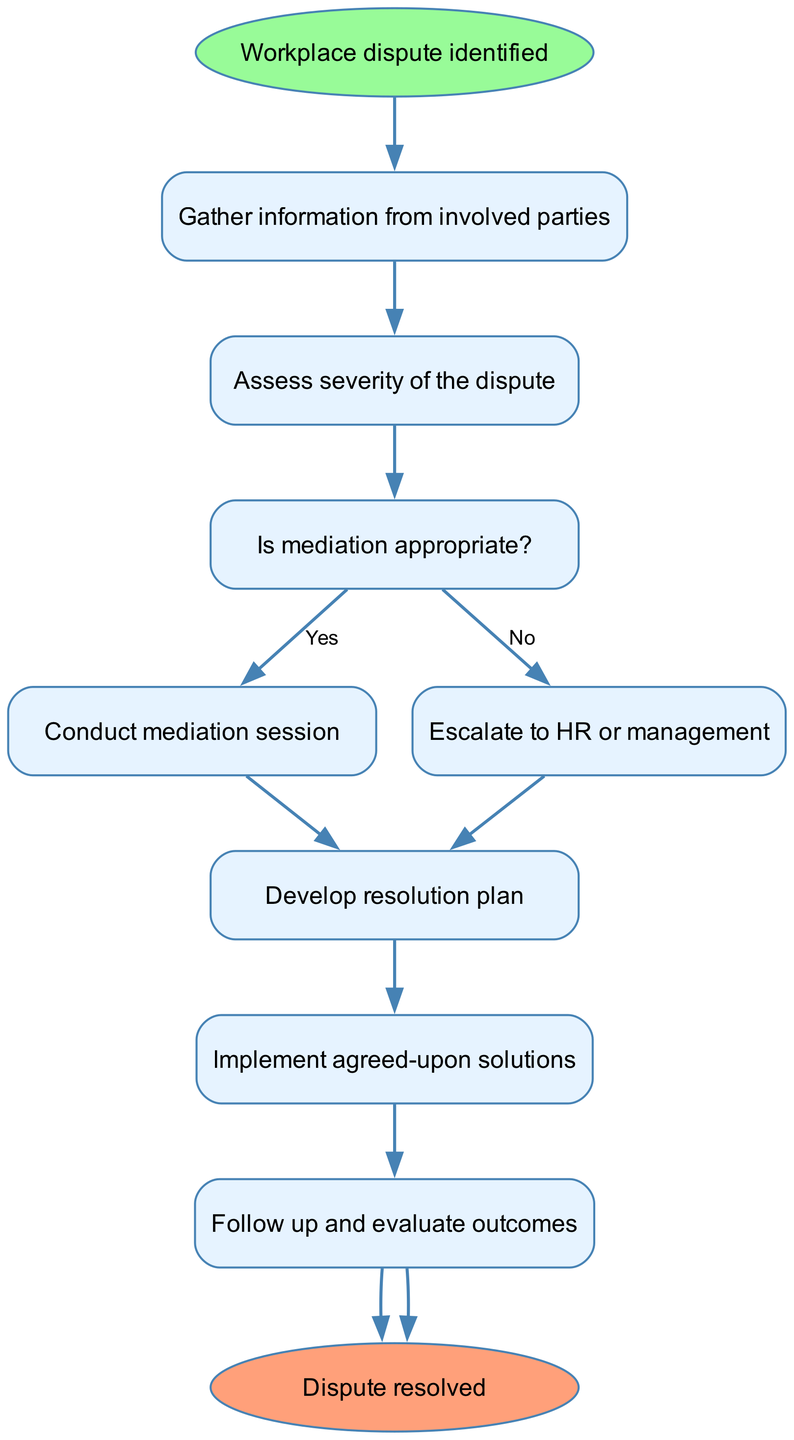What is the starting point of the decision-making process? The starting point of the process is explicitly stated as "Workplace dispute identified" in the diagram.
Answer: Workplace dispute identified How many steps are there in the decision-making process? Counting the steps listed in the diagram, there are a total of 8 steps, excluding the start and end nodes.
Answer: 8 What is the decision point regarding mediation? The decision point is clearly indicated as "Is mediation appropriate?" which branches into two options: Yes or No.
Answer: Is mediation appropriate? What is the next step after conducting a mediation session? Following the action "Conduct mediation session," the next step in the process is to "Develop resolution plan."
Answer: Develop resolution plan What action should be taken if mediation is not appropriate? If mediation is not appropriate, the diagram states to "Escalate to HR or management" as the next action.
Answer: Escalate to HR or management What happens after implementing agreed-upon solutions? After "Implement agreed-upon solutions," the next action mentioned is "Follow up and evaluate outcomes."
Answer: Follow up and evaluate outcomes Which nodes lead to the end of the diagram? The nodes that lead to the end of the diagram are "8" from "Follow up and evaluate outcomes," which directly connects to the "Dispute resolved" node.
Answer: 8 What is the purpose of the node labeled "Assess severity of the dispute"? The purpose of this node is to assess the seriousness of the dispute, determining the next steps based on the severity.
Answer: Assess severity of the dispute What color represents the end node in the diagram? The end node is represented in a distinct shade, specifically a light salmon color (specified as "#FFA07A") in the diagram.
Answer: light salmon 